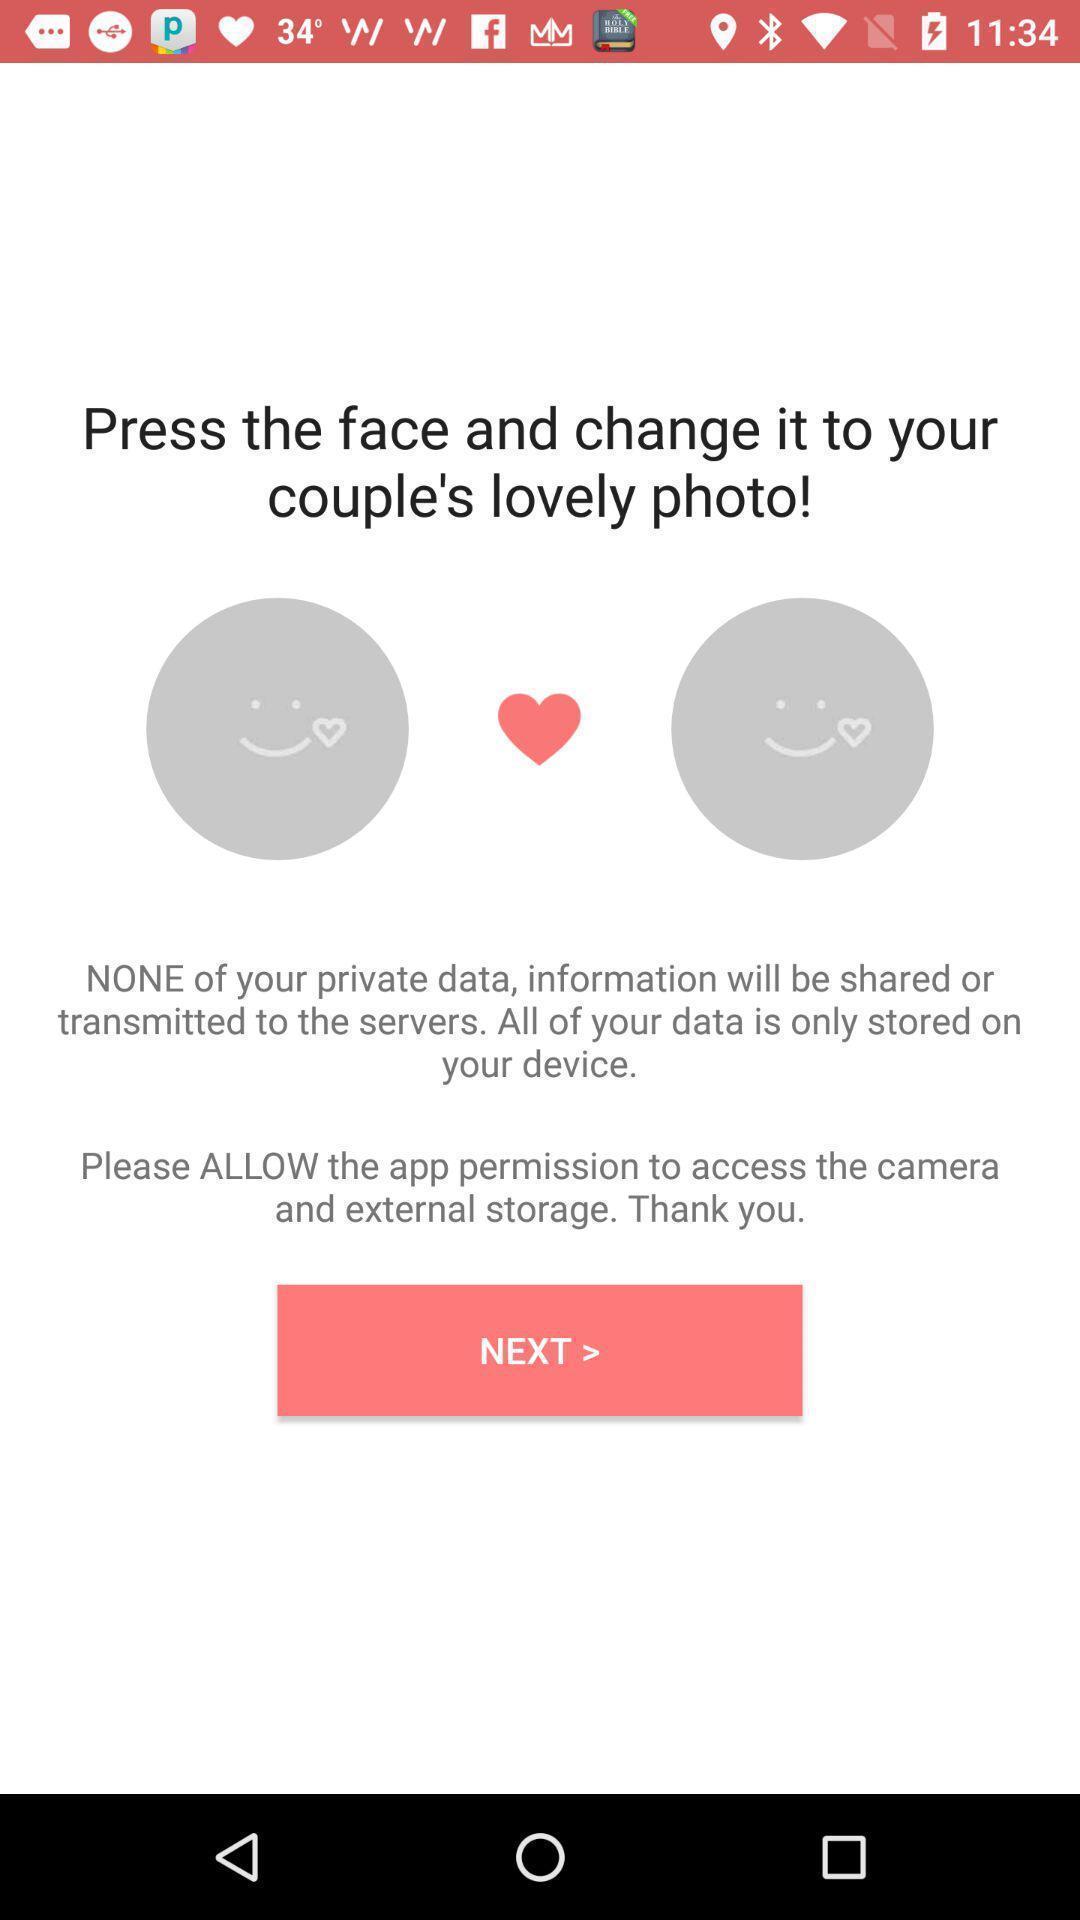What can you discern from this picture? Page displaying press the face and change. 